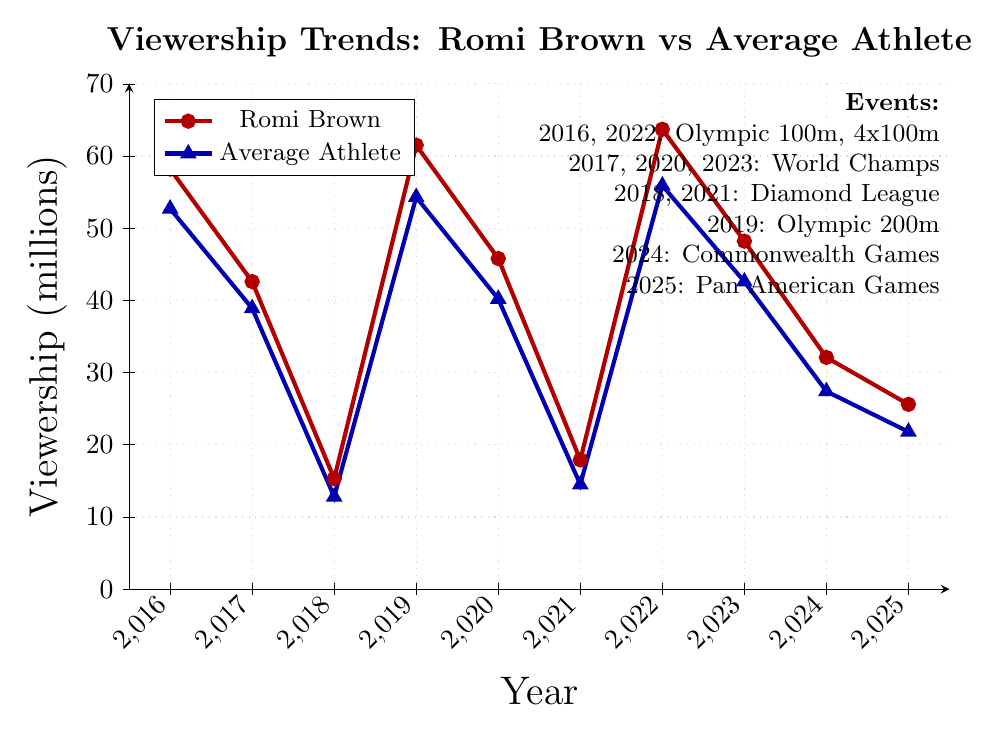What event in 2022 had the highest viewership for Romi Brown? The chart shows the viewership trends for Romi Brown and other athletes from 2016 to 2025. In 2022, Romi Brown's viewership was the highest compared to the other years, corresponding to the Olympic 4x100m Relay.
Answer: Olympic 4x100m Relay Which event had the largest difference in viewership between Romi Brown and the average athlete? By examining the vertical distances between the red and blue lines on the chart, you can see that the largest difference in viewership occurred in the 2022 Olympic 4x100m Relay. Romi Brown had 63.7 million viewers, while the average athlete had 55.9 million, resulting in a difference of 7.8 million.
Answer: Olympic 4x100m Relay How did Romi Brown's viewership trend compare to that of an average athlete from 2016 to 2025? Romi Brown's viewership generally followed a similar trend to that of the average athlete but was consistently higher. Both saw peaks in viewership during Olympic events and the World Championships, with both lines showing similar rises and falls over the years.
Answer: Romi Brown had consistently higher viewership than the average athlete Which year showed the lowest viewership for Romi Brown? By identifying the lowest point on the red line, the year with the lowest viewership for Romi Brown is 2018, with 15.3 million viewers for the Diamond League London event.
Answer: 2018 What is the viewership for Romi Brown in the 2019 Olympic 200m Final, and how does it compare to the average athlete's viewership in the same year? In the 2019 Olympic 200m Final, Romi Brown had 61.5 million viewers while the average athlete had 54.3 million viewers. This shows that Romi Brown had 7.2 million more viewers.
Answer: 61.5 million, 7.2 million more On which year did the World Championships 100m Final take place and what were the viewership numbers for Romi Brown compared to the average athlete? The World Championships 100m Final took place in 2017. Romi Brown had a viewership of 42.6 million, while the average athlete had 38.9 million viewers, indicating Romi Brown had more viewers.
Answer: 2017, Romi Brown had 42.6 million, and the average athlete had 38.9 million What is the average viewership for Romi Brown across all events from 2016 to 2025? To find the average viewership for Romi Brown, sum the viewership numbers and divide by the number of events. (58.2 + 42.6 + 15.3 + 61.5 + 45.8 + 17.9 + 63.7 + 48.2 + 32.1 + 25.6) / 10 gives an average of 41.09 million viewers.
Answer: 41.1 million In which year did Romi Brown experience a sharp increase in viewership compared to the previous year? The chart shows a significant jump in viewership for Romi Brown between 2018 and 2019, where the viewership increased from 15.3 million to 61.5 million, corresponding to the Olympic 200m Final.
Answer: 2019 How does the viewership for Romi Brown in the 2024 Commonwealth Games 100m Final compare to the Pan American Games 200m Final in 2025? In the 2024 Commonwealth Games 100m Final, Romi Brown had a viewership of 32.1 million, whereas in the 2025 Pan American Games 200m Final, Romi Brown had a viewership of 25.6 million. Thus, the 2024 event had higher viewership by 6.5 million.
Answer: 32.1 million in 2024, 6.5 million more 